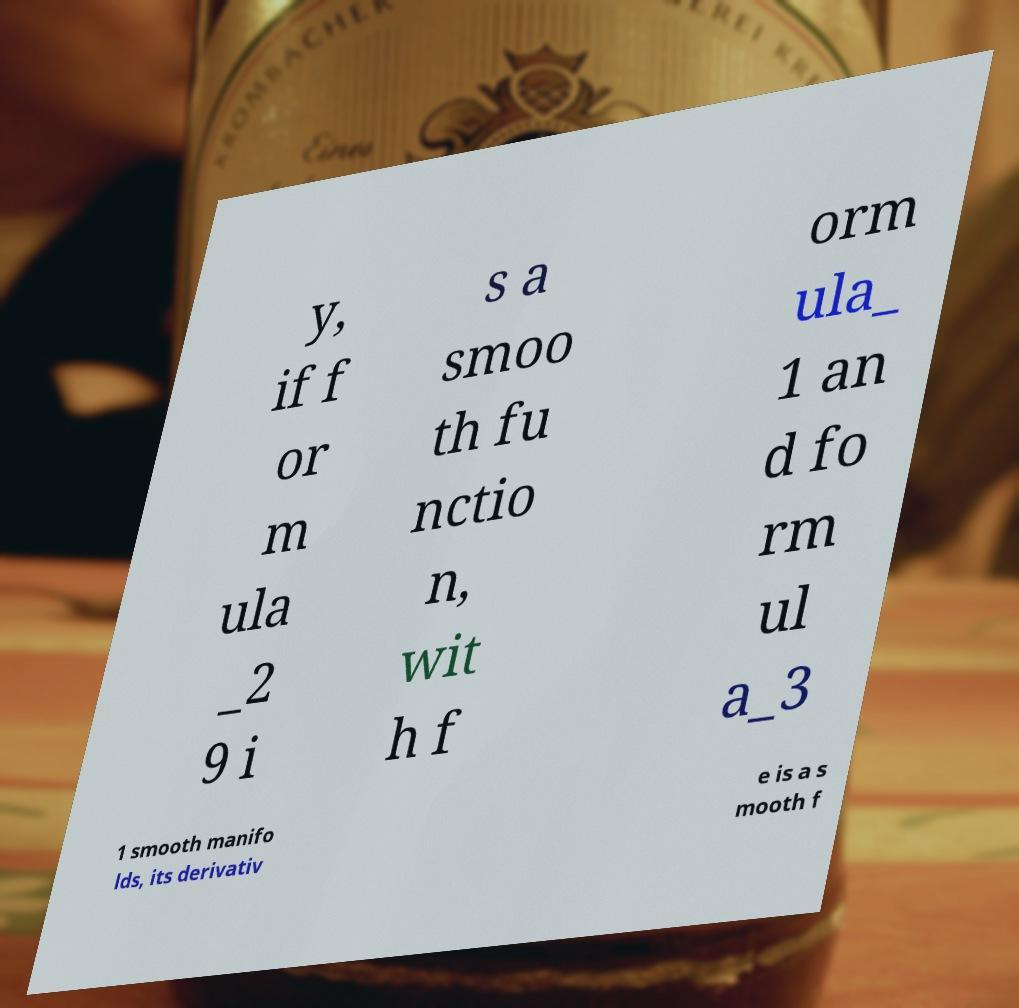Please identify and transcribe the text found in this image. y, if f or m ula _2 9 i s a smoo th fu nctio n, wit h f orm ula_ 1 an d fo rm ul a_3 1 smooth manifo lds, its derivativ e is a s mooth f 